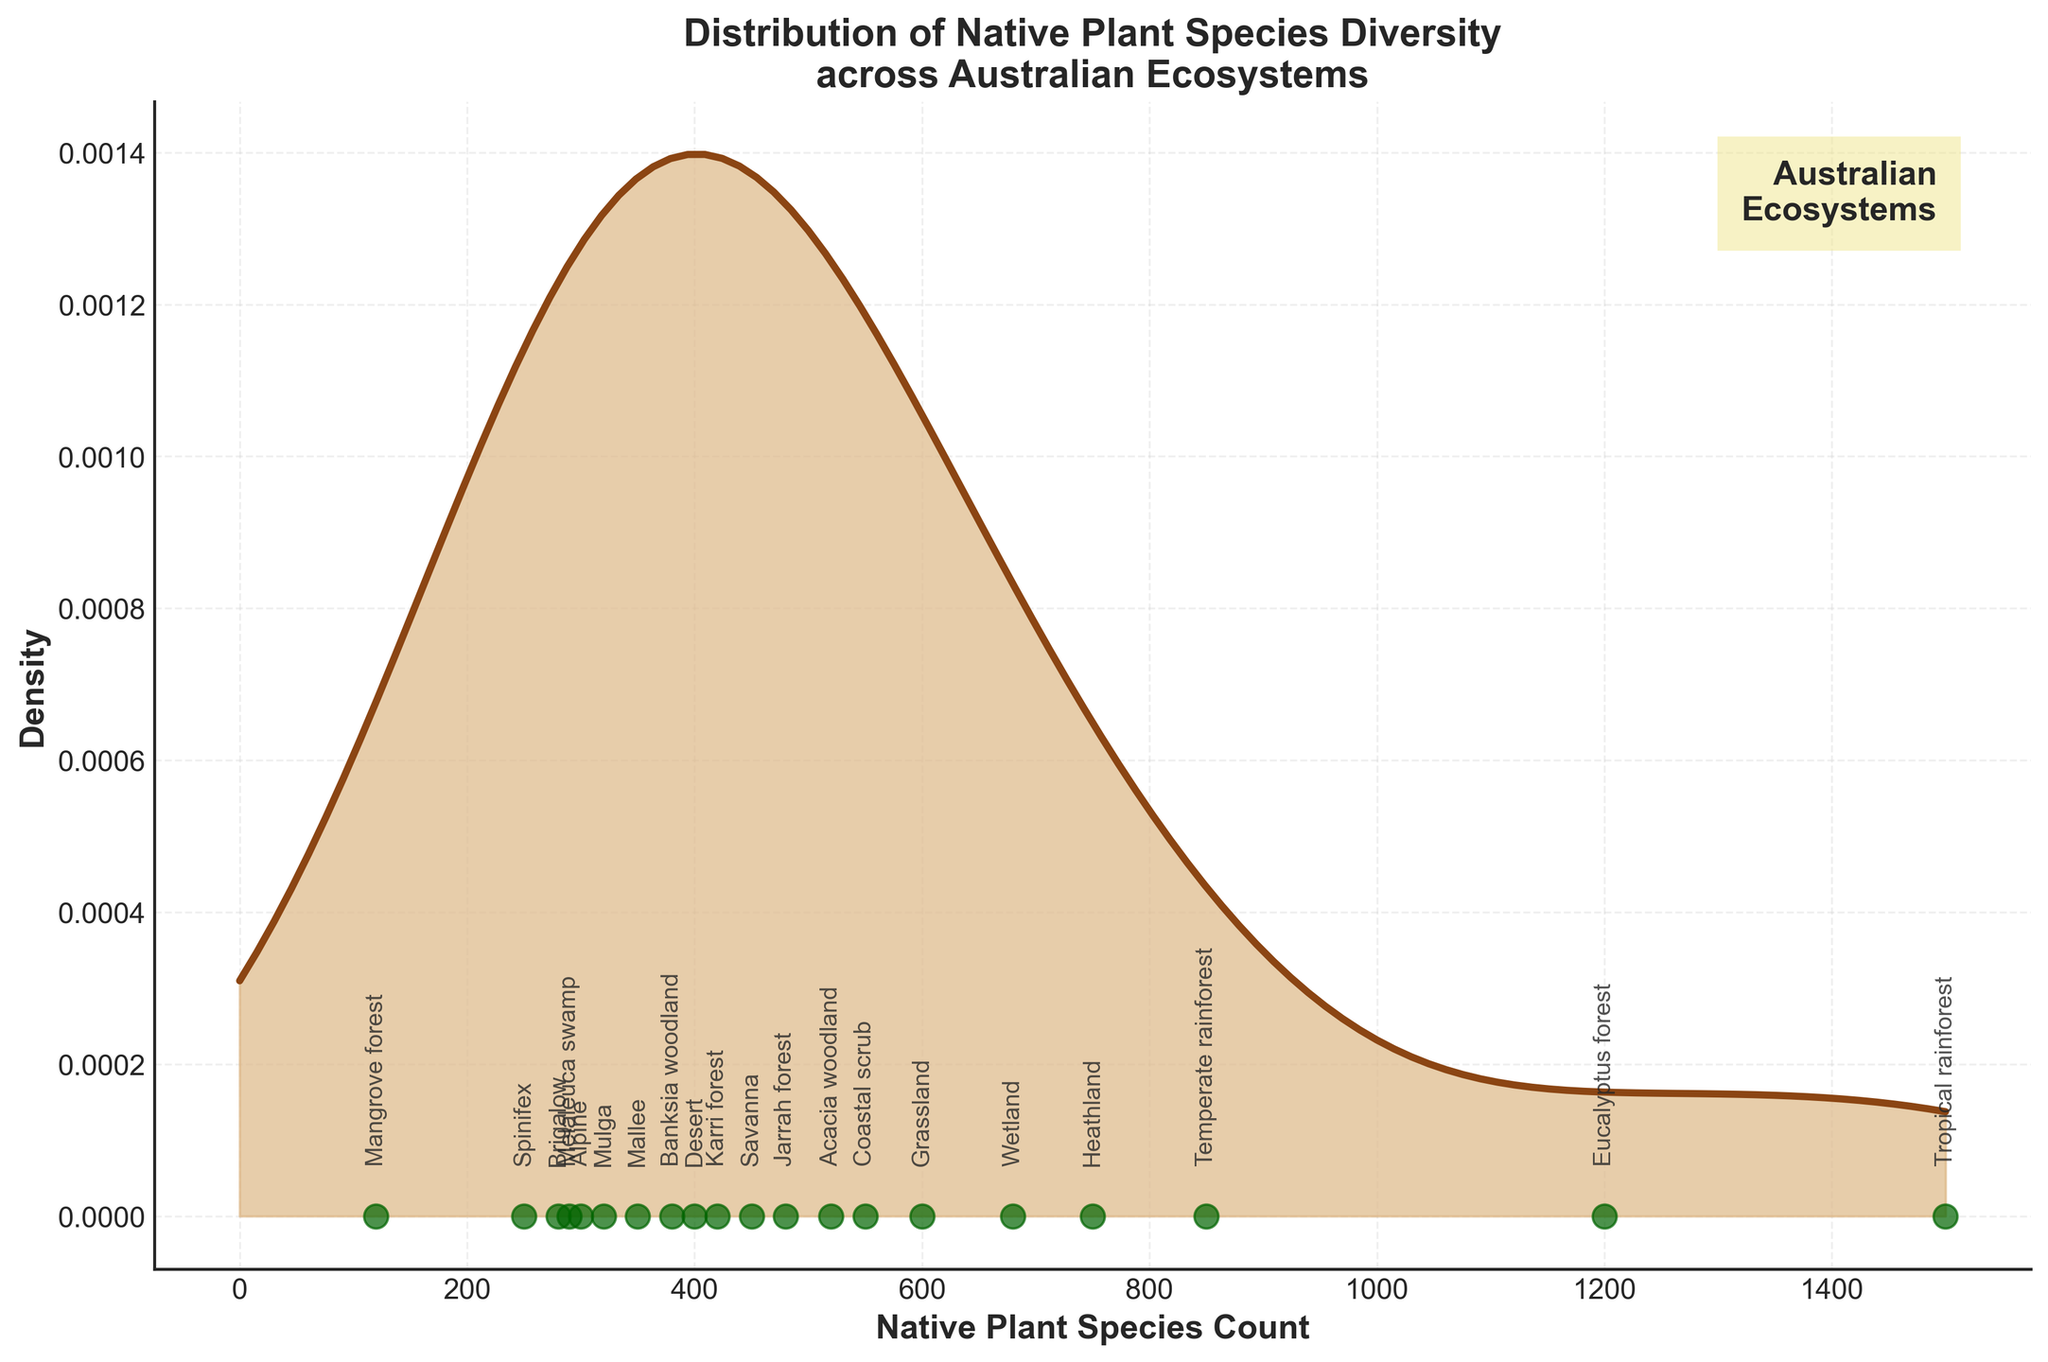What is the title of the plot? The title is located at the top of the plot and is clearly readable.
Answer: Distribution of Native Plant Species Diversity across Australian Ecosystems How many data points (ecosystems) are represented in the plot? By counting the number of labeled scatter points, we can determine the total number of data points.
Answer: 20 Which ecosystem has the highest species count? The scatter point with the highest x-axis value represents the ecosystem with the highest species count. Upon inspection, this is the Tropical rainforest.
Answer: Tropical rainforest Which ecosystem has the lowest species count? The scatter point with the lowest x-axis value represents the ecosystem with the lowest species count. Upon inspection, this is the Mangrove forest.
Answer: Mangrove forest What is the range of the species count values depicted in the plot? The range is found by subtracting the smallest species count from the largest, which are represented by the Tropical rainforest (1500) and the Mangrove forest (120).
Answer: 1380 What is the density peak value approximately at? The highest point of the density curve indicates the peak value. By following the peak on the plot's density curve to the x-axis, we get an approximate value.
Answer: Around 400-600 Which two ecosystems have similar species counts close to 600 species? By observing the scatter points around the 600 mark, we find Grassland (600) and Wetland (680).
Answer: Grassland and Wetland What can you infer about the diversity in Desert vs. Eucalyptus forest ecosystems? By comparing the scatter points for Desert (400) and Eucalyptus forest (1200), we see that Eucalyptus forest has 3 times more species compared to Desert.
Answer: Eucalyptus forest has significantly higher diversity than Desert Estimate the average species count across all ecosystems. By summing up the species counts and dividing by the number of ecosystems (20), which gives approximately (1500+850+1200+120+600+400+300+750+550+680+450+350+280+520+320+250+480+420+380+290)/20 = 14190/20
Answer: 710 Would you describe the distribution as having more high species count ecosystems or low species count ones? By observing the density curve and scatter points, we note that there are more ecosystems with low to mid-range species counts based on the higher density in this region.
Answer: More low to mid species count ecosystems 